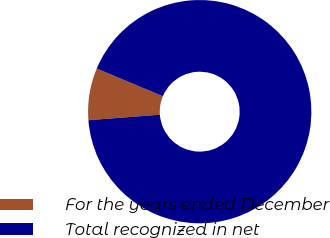Convert chart to OTSL. <chart><loc_0><loc_0><loc_500><loc_500><pie_chart><fcel>For the years ended December<fcel>Total recognized in net<nl><fcel>7.53%<fcel>92.47%<nl></chart> 